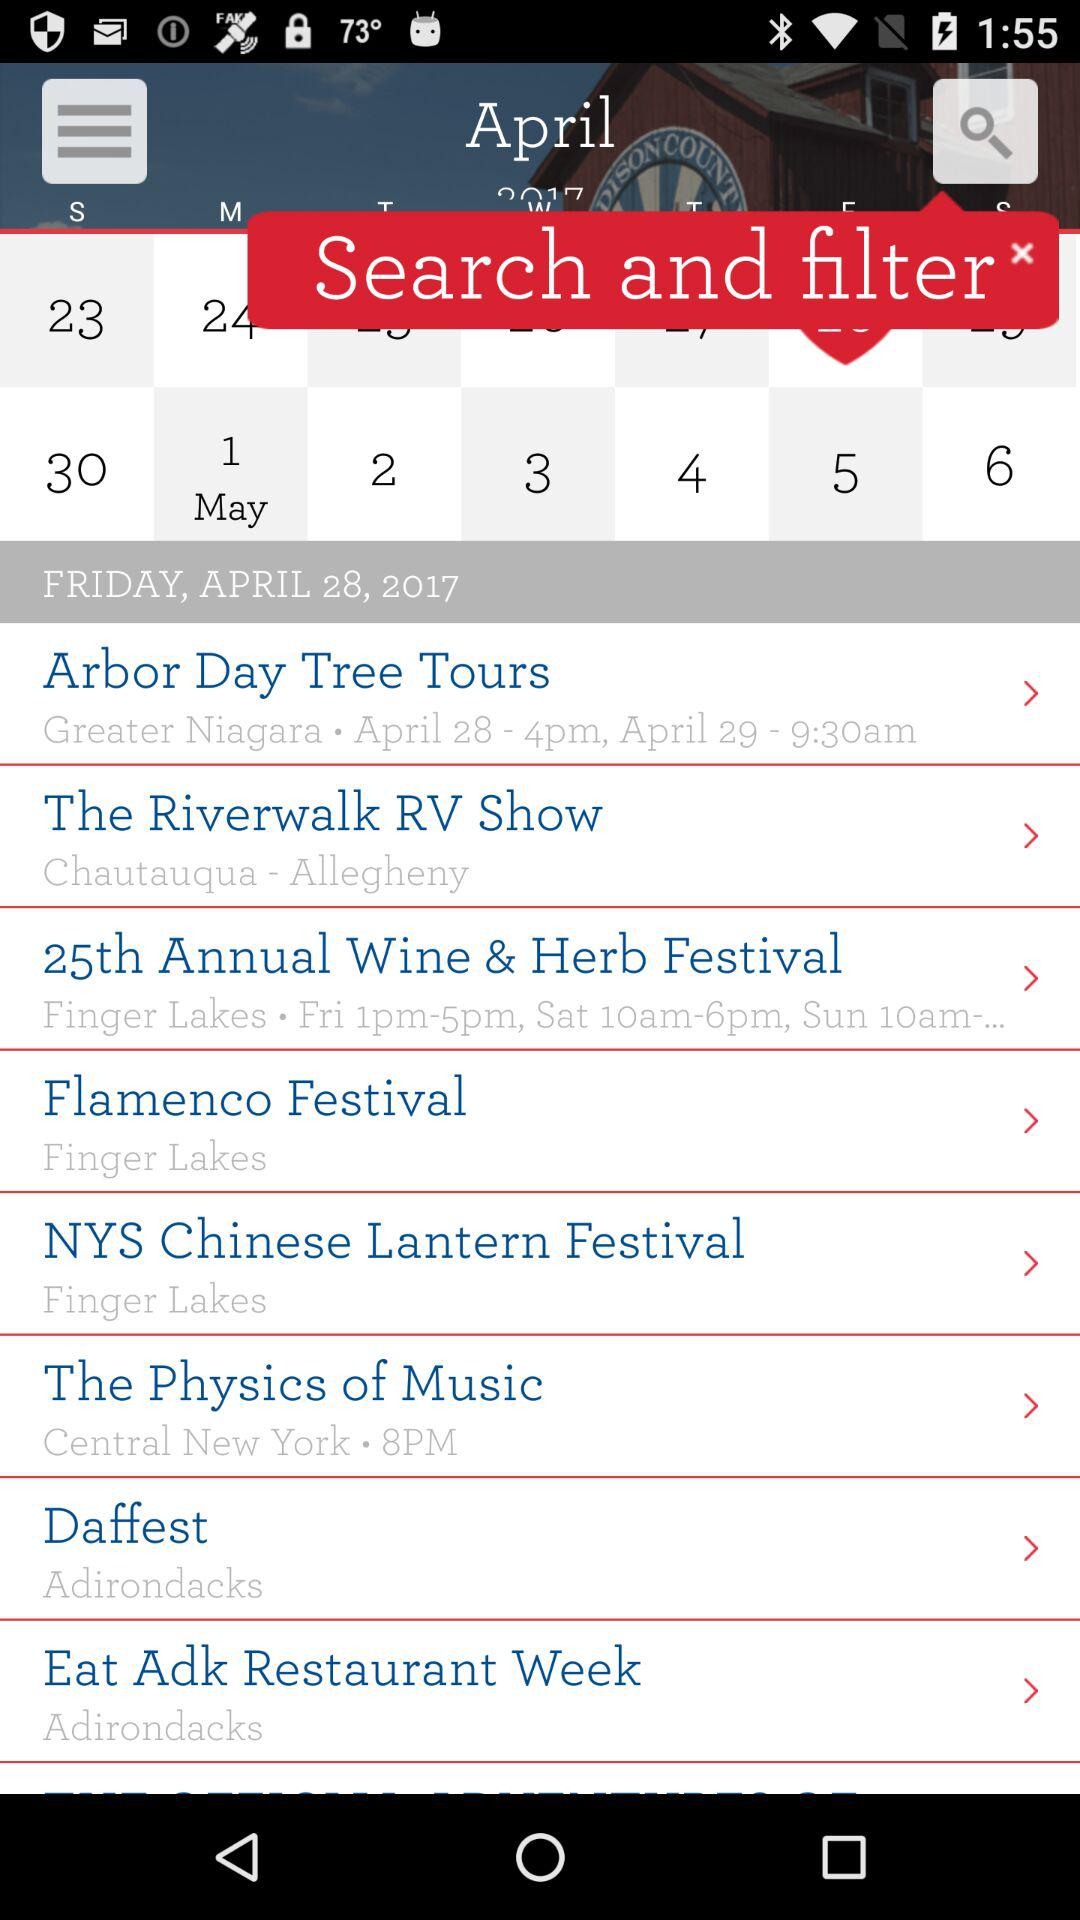What is the location given for "The Physics of Music"? The given location is Central New York. 